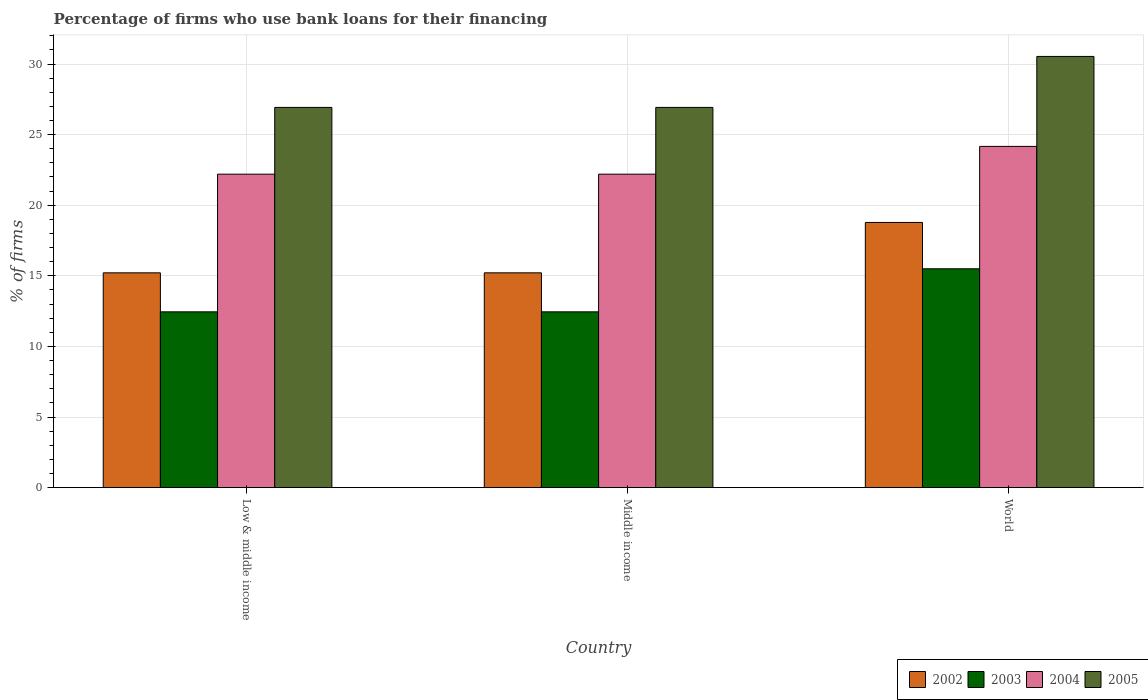How many groups of bars are there?
Your answer should be compact. 3. Are the number of bars per tick equal to the number of legend labels?
Your response must be concise. Yes. Are the number of bars on each tick of the X-axis equal?
Give a very brief answer. Yes. How many bars are there on the 1st tick from the left?
Offer a very short reply. 4. How many bars are there on the 2nd tick from the right?
Keep it short and to the point. 4. What is the label of the 2nd group of bars from the left?
Make the answer very short. Middle income. What is the percentage of firms who use bank loans for their financing in 2002 in World?
Provide a short and direct response. 18.78. Across all countries, what is the maximum percentage of firms who use bank loans for their financing in 2003?
Your response must be concise. 15.5. Across all countries, what is the minimum percentage of firms who use bank loans for their financing in 2003?
Give a very brief answer. 12.45. In which country was the percentage of firms who use bank loans for their financing in 2003 maximum?
Ensure brevity in your answer.  World. In which country was the percentage of firms who use bank loans for their financing in 2002 minimum?
Your answer should be very brief. Low & middle income. What is the total percentage of firms who use bank loans for their financing in 2005 in the graph?
Your response must be concise. 84.39. What is the difference between the percentage of firms who use bank loans for their financing in 2004 in Low & middle income and the percentage of firms who use bank loans for their financing in 2005 in World?
Your answer should be compact. -8.34. What is the average percentage of firms who use bank loans for their financing in 2003 per country?
Offer a terse response. 13.47. What is the difference between the percentage of firms who use bank loans for their financing of/in 2002 and percentage of firms who use bank loans for their financing of/in 2005 in World?
Provide a short and direct response. -11.76. In how many countries, is the percentage of firms who use bank loans for their financing in 2004 greater than 14 %?
Offer a very short reply. 3. What is the ratio of the percentage of firms who use bank loans for their financing in 2004 in Middle income to that in World?
Ensure brevity in your answer.  0.92. Is the difference between the percentage of firms who use bank loans for their financing in 2002 in Low & middle income and World greater than the difference between the percentage of firms who use bank loans for their financing in 2005 in Low & middle income and World?
Offer a very short reply. Yes. What is the difference between the highest and the second highest percentage of firms who use bank loans for their financing in 2005?
Offer a terse response. -3.61. What is the difference between the highest and the lowest percentage of firms who use bank loans for their financing in 2002?
Make the answer very short. 3.57. Is it the case that in every country, the sum of the percentage of firms who use bank loans for their financing in 2003 and percentage of firms who use bank loans for their financing in 2005 is greater than the sum of percentage of firms who use bank loans for their financing in 2002 and percentage of firms who use bank loans for their financing in 2004?
Your answer should be compact. No. What does the 4th bar from the right in Low & middle income represents?
Make the answer very short. 2002. How many countries are there in the graph?
Keep it short and to the point. 3. What is the difference between two consecutive major ticks on the Y-axis?
Offer a very short reply. 5. Where does the legend appear in the graph?
Offer a terse response. Bottom right. How many legend labels are there?
Your response must be concise. 4. How are the legend labels stacked?
Give a very brief answer. Horizontal. What is the title of the graph?
Make the answer very short. Percentage of firms who use bank loans for their financing. What is the label or title of the Y-axis?
Keep it short and to the point. % of firms. What is the % of firms in 2002 in Low & middle income?
Your response must be concise. 15.21. What is the % of firms in 2003 in Low & middle income?
Provide a short and direct response. 12.45. What is the % of firms of 2004 in Low & middle income?
Your answer should be very brief. 22.2. What is the % of firms of 2005 in Low & middle income?
Ensure brevity in your answer.  26.93. What is the % of firms in 2002 in Middle income?
Give a very brief answer. 15.21. What is the % of firms in 2003 in Middle income?
Offer a very short reply. 12.45. What is the % of firms of 2004 in Middle income?
Make the answer very short. 22.2. What is the % of firms of 2005 in Middle income?
Provide a succinct answer. 26.93. What is the % of firms in 2002 in World?
Make the answer very short. 18.78. What is the % of firms of 2004 in World?
Your response must be concise. 24.17. What is the % of firms of 2005 in World?
Offer a very short reply. 30.54. Across all countries, what is the maximum % of firms of 2002?
Offer a very short reply. 18.78. Across all countries, what is the maximum % of firms in 2004?
Your response must be concise. 24.17. Across all countries, what is the maximum % of firms of 2005?
Keep it short and to the point. 30.54. Across all countries, what is the minimum % of firms in 2002?
Your answer should be compact. 15.21. Across all countries, what is the minimum % of firms in 2003?
Provide a short and direct response. 12.45. Across all countries, what is the minimum % of firms of 2004?
Offer a very short reply. 22.2. Across all countries, what is the minimum % of firms in 2005?
Give a very brief answer. 26.93. What is the total % of firms of 2002 in the graph?
Offer a terse response. 49.21. What is the total % of firms of 2003 in the graph?
Your answer should be compact. 40.4. What is the total % of firms in 2004 in the graph?
Your answer should be compact. 68.57. What is the total % of firms in 2005 in the graph?
Keep it short and to the point. 84.39. What is the difference between the % of firms in 2002 in Low & middle income and that in Middle income?
Make the answer very short. 0. What is the difference between the % of firms of 2003 in Low & middle income and that in Middle income?
Your answer should be very brief. 0. What is the difference between the % of firms in 2005 in Low & middle income and that in Middle income?
Make the answer very short. 0. What is the difference between the % of firms in 2002 in Low & middle income and that in World?
Provide a succinct answer. -3.57. What is the difference between the % of firms in 2003 in Low & middle income and that in World?
Your answer should be compact. -3.05. What is the difference between the % of firms of 2004 in Low & middle income and that in World?
Offer a very short reply. -1.97. What is the difference between the % of firms of 2005 in Low & middle income and that in World?
Offer a very short reply. -3.61. What is the difference between the % of firms of 2002 in Middle income and that in World?
Provide a short and direct response. -3.57. What is the difference between the % of firms in 2003 in Middle income and that in World?
Offer a terse response. -3.05. What is the difference between the % of firms of 2004 in Middle income and that in World?
Your answer should be compact. -1.97. What is the difference between the % of firms of 2005 in Middle income and that in World?
Offer a very short reply. -3.61. What is the difference between the % of firms of 2002 in Low & middle income and the % of firms of 2003 in Middle income?
Offer a terse response. 2.76. What is the difference between the % of firms of 2002 in Low & middle income and the % of firms of 2004 in Middle income?
Provide a succinct answer. -6.99. What is the difference between the % of firms of 2002 in Low & middle income and the % of firms of 2005 in Middle income?
Give a very brief answer. -11.72. What is the difference between the % of firms in 2003 in Low & middle income and the % of firms in 2004 in Middle income?
Make the answer very short. -9.75. What is the difference between the % of firms in 2003 in Low & middle income and the % of firms in 2005 in Middle income?
Give a very brief answer. -14.48. What is the difference between the % of firms in 2004 in Low & middle income and the % of firms in 2005 in Middle income?
Make the answer very short. -4.73. What is the difference between the % of firms in 2002 in Low & middle income and the % of firms in 2003 in World?
Give a very brief answer. -0.29. What is the difference between the % of firms of 2002 in Low & middle income and the % of firms of 2004 in World?
Provide a succinct answer. -8.95. What is the difference between the % of firms of 2002 in Low & middle income and the % of firms of 2005 in World?
Make the answer very short. -15.33. What is the difference between the % of firms in 2003 in Low & middle income and the % of firms in 2004 in World?
Your answer should be compact. -11.72. What is the difference between the % of firms in 2003 in Low & middle income and the % of firms in 2005 in World?
Make the answer very short. -18.09. What is the difference between the % of firms of 2004 in Low & middle income and the % of firms of 2005 in World?
Give a very brief answer. -8.34. What is the difference between the % of firms of 2002 in Middle income and the % of firms of 2003 in World?
Your answer should be compact. -0.29. What is the difference between the % of firms of 2002 in Middle income and the % of firms of 2004 in World?
Your answer should be compact. -8.95. What is the difference between the % of firms in 2002 in Middle income and the % of firms in 2005 in World?
Keep it short and to the point. -15.33. What is the difference between the % of firms in 2003 in Middle income and the % of firms in 2004 in World?
Provide a succinct answer. -11.72. What is the difference between the % of firms in 2003 in Middle income and the % of firms in 2005 in World?
Your response must be concise. -18.09. What is the difference between the % of firms of 2004 in Middle income and the % of firms of 2005 in World?
Your answer should be compact. -8.34. What is the average % of firms in 2002 per country?
Offer a very short reply. 16.4. What is the average % of firms in 2003 per country?
Make the answer very short. 13.47. What is the average % of firms of 2004 per country?
Offer a very short reply. 22.86. What is the average % of firms in 2005 per country?
Keep it short and to the point. 28.13. What is the difference between the % of firms of 2002 and % of firms of 2003 in Low & middle income?
Your response must be concise. 2.76. What is the difference between the % of firms of 2002 and % of firms of 2004 in Low & middle income?
Your answer should be compact. -6.99. What is the difference between the % of firms in 2002 and % of firms in 2005 in Low & middle income?
Keep it short and to the point. -11.72. What is the difference between the % of firms in 2003 and % of firms in 2004 in Low & middle income?
Your answer should be compact. -9.75. What is the difference between the % of firms in 2003 and % of firms in 2005 in Low & middle income?
Offer a terse response. -14.48. What is the difference between the % of firms of 2004 and % of firms of 2005 in Low & middle income?
Ensure brevity in your answer.  -4.73. What is the difference between the % of firms in 2002 and % of firms in 2003 in Middle income?
Provide a short and direct response. 2.76. What is the difference between the % of firms in 2002 and % of firms in 2004 in Middle income?
Your answer should be very brief. -6.99. What is the difference between the % of firms of 2002 and % of firms of 2005 in Middle income?
Your response must be concise. -11.72. What is the difference between the % of firms of 2003 and % of firms of 2004 in Middle income?
Ensure brevity in your answer.  -9.75. What is the difference between the % of firms in 2003 and % of firms in 2005 in Middle income?
Ensure brevity in your answer.  -14.48. What is the difference between the % of firms of 2004 and % of firms of 2005 in Middle income?
Offer a very short reply. -4.73. What is the difference between the % of firms of 2002 and % of firms of 2003 in World?
Your answer should be very brief. 3.28. What is the difference between the % of firms in 2002 and % of firms in 2004 in World?
Provide a short and direct response. -5.39. What is the difference between the % of firms of 2002 and % of firms of 2005 in World?
Your answer should be very brief. -11.76. What is the difference between the % of firms of 2003 and % of firms of 2004 in World?
Make the answer very short. -8.67. What is the difference between the % of firms of 2003 and % of firms of 2005 in World?
Provide a succinct answer. -15.04. What is the difference between the % of firms of 2004 and % of firms of 2005 in World?
Keep it short and to the point. -6.37. What is the ratio of the % of firms in 2002 in Low & middle income to that in Middle income?
Keep it short and to the point. 1. What is the ratio of the % of firms of 2004 in Low & middle income to that in Middle income?
Your response must be concise. 1. What is the ratio of the % of firms of 2002 in Low & middle income to that in World?
Ensure brevity in your answer.  0.81. What is the ratio of the % of firms in 2003 in Low & middle income to that in World?
Make the answer very short. 0.8. What is the ratio of the % of firms of 2004 in Low & middle income to that in World?
Provide a short and direct response. 0.92. What is the ratio of the % of firms of 2005 in Low & middle income to that in World?
Provide a succinct answer. 0.88. What is the ratio of the % of firms in 2002 in Middle income to that in World?
Make the answer very short. 0.81. What is the ratio of the % of firms of 2003 in Middle income to that in World?
Keep it short and to the point. 0.8. What is the ratio of the % of firms of 2004 in Middle income to that in World?
Provide a short and direct response. 0.92. What is the ratio of the % of firms of 2005 in Middle income to that in World?
Ensure brevity in your answer.  0.88. What is the difference between the highest and the second highest % of firms of 2002?
Offer a very short reply. 3.57. What is the difference between the highest and the second highest % of firms in 2003?
Make the answer very short. 3.05. What is the difference between the highest and the second highest % of firms of 2004?
Your response must be concise. 1.97. What is the difference between the highest and the second highest % of firms in 2005?
Provide a short and direct response. 3.61. What is the difference between the highest and the lowest % of firms of 2002?
Keep it short and to the point. 3.57. What is the difference between the highest and the lowest % of firms of 2003?
Your response must be concise. 3.05. What is the difference between the highest and the lowest % of firms of 2004?
Give a very brief answer. 1.97. What is the difference between the highest and the lowest % of firms of 2005?
Ensure brevity in your answer.  3.61. 